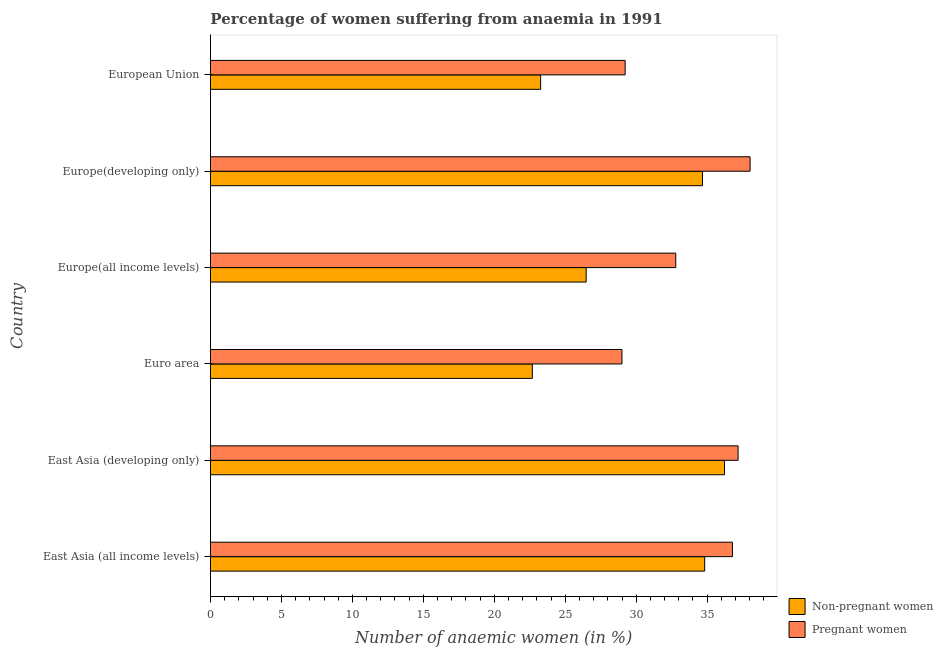How many different coloured bars are there?
Provide a succinct answer. 2. How many groups of bars are there?
Make the answer very short. 6. How many bars are there on the 3rd tick from the top?
Offer a very short reply. 2. How many bars are there on the 5th tick from the bottom?
Make the answer very short. 2. What is the label of the 1st group of bars from the top?
Your answer should be compact. European Union. In how many cases, is the number of bars for a given country not equal to the number of legend labels?
Your answer should be very brief. 0. What is the percentage of non-pregnant anaemic women in Europe(all income levels)?
Your answer should be compact. 26.47. Across all countries, what is the maximum percentage of pregnant anaemic women?
Make the answer very short. 38.02. Across all countries, what is the minimum percentage of pregnant anaemic women?
Offer a very short reply. 29. In which country was the percentage of pregnant anaemic women maximum?
Keep it short and to the point. Europe(developing only). What is the total percentage of non-pregnant anaemic women in the graph?
Keep it short and to the point. 178.14. What is the difference between the percentage of non-pregnant anaemic women in East Asia (developing only) and that in Europe(all income levels)?
Keep it short and to the point. 9.75. What is the difference between the percentage of non-pregnant anaemic women in Europe(developing only) and the percentage of pregnant anaemic women in Euro area?
Ensure brevity in your answer.  5.68. What is the average percentage of non-pregnant anaemic women per country?
Keep it short and to the point. 29.69. What is the difference between the percentage of pregnant anaemic women and percentage of non-pregnant anaemic women in Europe(developing only)?
Your response must be concise. 3.35. What is the ratio of the percentage of pregnant anaemic women in Europe(all income levels) to that in Europe(developing only)?
Make the answer very short. 0.86. Is the percentage of non-pregnant anaemic women in East Asia (developing only) less than that in Europe(all income levels)?
Your response must be concise. No. Is the difference between the percentage of pregnant anaemic women in East Asia (developing only) and Europe(developing only) greater than the difference between the percentage of non-pregnant anaemic women in East Asia (developing only) and Europe(developing only)?
Your answer should be very brief. No. What is the difference between the highest and the second highest percentage of non-pregnant anaemic women?
Provide a short and direct response. 1.4. What is the difference between the highest and the lowest percentage of non-pregnant anaemic women?
Your response must be concise. 13.54. In how many countries, is the percentage of non-pregnant anaemic women greater than the average percentage of non-pregnant anaemic women taken over all countries?
Your answer should be very brief. 3. Is the sum of the percentage of pregnant anaemic women in East Asia (all income levels) and East Asia (developing only) greater than the maximum percentage of non-pregnant anaemic women across all countries?
Make the answer very short. Yes. What does the 1st bar from the top in European Union represents?
Make the answer very short. Pregnant women. What does the 1st bar from the bottom in Euro area represents?
Provide a succinct answer. Non-pregnant women. How many bars are there?
Your response must be concise. 12. What is the difference between two consecutive major ticks on the X-axis?
Provide a short and direct response. 5. Does the graph contain grids?
Make the answer very short. No. Where does the legend appear in the graph?
Give a very brief answer. Bottom right. How are the legend labels stacked?
Offer a very short reply. Vertical. What is the title of the graph?
Your answer should be compact. Percentage of women suffering from anaemia in 1991. What is the label or title of the X-axis?
Provide a succinct answer. Number of anaemic women (in %). What is the Number of anaemic women (in %) of Non-pregnant women in East Asia (all income levels)?
Give a very brief answer. 34.83. What is the Number of anaemic women (in %) in Pregnant women in East Asia (all income levels)?
Offer a very short reply. 36.78. What is the Number of anaemic women (in %) in Non-pregnant women in East Asia (developing only)?
Make the answer very short. 36.22. What is the Number of anaemic women (in %) in Pregnant women in East Asia (developing only)?
Your answer should be very brief. 37.18. What is the Number of anaemic women (in %) of Non-pregnant women in Euro area?
Offer a terse response. 22.68. What is the Number of anaemic women (in %) of Pregnant women in Euro area?
Offer a terse response. 29. What is the Number of anaemic women (in %) of Non-pregnant women in Europe(all income levels)?
Offer a terse response. 26.47. What is the Number of anaemic women (in %) in Pregnant women in Europe(all income levels)?
Give a very brief answer. 32.79. What is the Number of anaemic women (in %) of Non-pregnant women in Europe(developing only)?
Your answer should be compact. 34.67. What is the Number of anaemic women (in %) in Pregnant women in Europe(developing only)?
Your answer should be very brief. 38.02. What is the Number of anaemic women (in %) of Non-pregnant women in European Union?
Your answer should be very brief. 23.27. What is the Number of anaemic women (in %) of Pregnant women in European Union?
Give a very brief answer. 29.22. Across all countries, what is the maximum Number of anaemic women (in %) of Non-pregnant women?
Ensure brevity in your answer.  36.22. Across all countries, what is the maximum Number of anaemic women (in %) in Pregnant women?
Give a very brief answer. 38.02. Across all countries, what is the minimum Number of anaemic women (in %) of Non-pregnant women?
Your answer should be compact. 22.68. Across all countries, what is the minimum Number of anaemic women (in %) in Pregnant women?
Your response must be concise. 29. What is the total Number of anaemic women (in %) in Non-pregnant women in the graph?
Offer a very short reply. 178.14. What is the total Number of anaemic women (in %) of Pregnant women in the graph?
Make the answer very short. 202.99. What is the difference between the Number of anaemic women (in %) of Non-pregnant women in East Asia (all income levels) and that in East Asia (developing only)?
Your response must be concise. -1.4. What is the difference between the Number of anaemic women (in %) of Pregnant women in East Asia (all income levels) and that in East Asia (developing only)?
Provide a succinct answer. -0.4. What is the difference between the Number of anaemic women (in %) in Non-pregnant women in East Asia (all income levels) and that in Euro area?
Your answer should be compact. 12.15. What is the difference between the Number of anaemic women (in %) of Pregnant women in East Asia (all income levels) and that in Euro area?
Your answer should be compact. 7.79. What is the difference between the Number of anaemic women (in %) of Non-pregnant women in East Asia (all income levels) and that in Europe(all income levels)?
Provide a succinct answer. 8.35. What is the difference between the Number of anaemic women (in %) of Pregnant women in East Asia (all income levels) and that in Europe(all income levels)?
Provide a succinct answer. 4. What is the difference between the Number of anaemic women (in %) of Non-pregnant women in East Asia (all income levels) and that in Europe(developing only)?
Keep it short and to the point. 0.15. What is the difference between the Number of anaemic women (in %) of Pregnant women in East Asia (all income levels) and that in Europe(developing only)?
Your answer should be very brief. -1.24. What is the difference between the Number of anaemic women (in %) in Non-pregnant women in East Asia (all income levels) and that in European Union?
Provide a succinct answer. 11.56. What is the difference between the Number of anaemic women (in %) of Pregnant women in East Asia (all income levels) and that in European Union?
Your response must be concise. 7.56. What is the difference between the Number of anaemic women (in %) of Non-pregnant women in East Asia (developing only) and that in Euro area?
Your answer should be very brief. 13.54. What is the difference between the Number of anaemic women (in %) of Pregnant women in East Asia (developing only) and that in Euro area?
Your answer should be compact. 8.18. What is the difference between the Number of anaemic women (in %) in Non-pregnant women in East Asia (developing only) and that in Europe(all income levels)?
Your response must be concise. 9.75. What is the difference between the Number of anaemic women (in %) in Pregnant women in East Asia (developing only) and that in Europe(all income levels)?
Provide a succinct answer. 4.39. What is the difference between the Number of anaemic women (in %) in Non-pregnant women in East Asia (developing only) and that in Europe(developing only)?
Your answer should be very brief. 1.55. What is the difference between the Number of anaemic women (in %) of Pregnant women in East Asia (developing only) and that in Europe(developing only)?
Your answer should be very brief. -0.85. What is the difference between the Number of anaemic women (in %) of Non-pregnant women in East Asia (developing only) and that in European Union?
Ensure brevity in your answer.  12.96. What is the difference between the Number of anaemic women (in %) in Pregnant women in East Asia (developing only) and that in European Union?
Offer a terse response. 7.96. What is the difference between the Number of anaemic women (in %) of Non-pregnant women in Euro area and that in Europe(all income levels)?
Give a very brief answer. -3.79. What is the difference between the Number of anaemic women (in %) in Pregnant women in Euro area and that in Europe(all income levels)?
Your answer should be very brief. -3.79. What is the difference between the Number of anaemic women (in %) of Non-pregnant women in Euro area and that in Europe(developing only)?
Offer a terse response. -11.99. What is the difference between the Number of anaemic women (in %) in Pregnant women in Euro area and that in Europe(developing only)?
Your answer should be very brief. -9.03. What is the difference between the Number of anaemic women (in %) in Non-pregnant women in Euro area and that in European Union?
Provide a succinct answer. -0.59. What is the difference between the Number of anaemic women (in %) of Pregnant women in Euro area and that in European Union?
Offer a very short reply. -0.23. What is the difference between the Number of anaemic women (in %) in Non-pregnant women in Europe(all income levels) and that in Europe(developing only)?
Your response must be concise. -8.2. What is the difference between the Number of anaemic women (in %) of Pregnant women in Europe(all income levels) and that in Europe(developing only)?
Give a very brief answer. -5.24. What is the difference between the Number of anaemic women (in %) in Non-pregnant women in Europe(all income levels) and that in European Union?
Give a very brief answer. 3.21. What is the difference between the Number of anaemic women (in %) of Pregnant women in Europe(all income levels) and that in European Union?
Provide a succinct answer. 3.57. What is the difference between the Number of anaemic women (in %) in Non-pregnant women in Europe(developing only) and that in European Union?
Give a very brief answer. 11.4. What is the difference between the Number of anaemic women (in %) of Pregnant women in Europe(developing only) and that in European Union?
Your answer should be very brief. 8.8. What is the difference between the Number of anaemic women (in %) in Non-pregnant women in East Asia (all income levels) and the Number of anaemic women (in %) in Pregnant women in East Asia (developing only)?
Your answer should be compact. -2.35. What is the difference between the Number of anaemic women (in %) of Non-pregnant women in East Asia (all income levels) and the Number of anaemic women (in %) of Pregnant women in Euro area?
Your answer should be compact. 5.83. What is the difference between the Number of anaemic women (in %) of Non-pregnant women in East Asia (all income levels) and the Number of anaemic women (in %) of Pregnant women in Europe(all income levels)?
Make the answer very short. 2.04. What is the difference between the Number of anaemic women (in %) of Non-pregnant women in East Asia (all income levels) and the Number of anaemic women (in %) of Pregnant women in Europe(developing only)?
Keep it short and to the point. -3.2. What is the difference between the Number of anaemic women (in %) of Non-pregnant women in East Asia (all income levels) and the Number of anaemic women (in %) of Pregnant women in European Union?
Give a very brief answer. 5.6. What is the difference between the Number of anaemic women (in %) in Non-pregnant women in East Asia (developing only) and the Number of anaemic women (in %) in Pregnant women in Euro area?
Make the answer very short. 7.23. What is the difference between the Number of anaemic women (in %) in Non-pregnant women in East Asia (developing only) and the Number of anaemic women (in %) in Pregnant women in Europe(all income levels)?
Your answer should be compact. 3.44. What is the difference between the Number of anaemic women (in %) of Non-pregnant women in East Asia (developing only) and the Number of anaemic women (in %) of Pregnant women in Europe(developing only)?
Keep it short and to the point. -1.8. What is the difference between the Number of anaemic women (in %) in Non-pregnant women in East Asia (developing only) and the Number of anaemic women (in %) in Pregnant women in European Union?
Give a very brief answer. 7. What is the difference between the Number of anaemic women (in %) of Non-pregnant women in Euro area and the Number of anaemic women (in %) of Pregnant women in Europe(all income levels)?
Your response must be concise. -10.11. What is the difference between the Number of anaemic women (in %) of Non-pregnant women in Euro area and the Number of anaemic women (in %) of Pregnant women in Europe(developing only)?
Your answer should be very brief. -15.34. What is the difference between the Number of anaemic women (in %) in Non-pregnant women in Euro area and the Number of anaemic women (in %) in Pregnant women in European Union?
Ensure brevity in your answer.  -6.54. What is the difference between the Number of anaemic women (in %) in Non-pregnant women in Europe(all income levels) and the Number of anaemic women (in %) in Pregnant women in Europe(developing only)?
Provide a short and direct response. -11.55. What is the difference between the Number of anaemic women (in %) in Non-pregnant women in Europe(all income levels) and the Number of anaemic women (in %) in Pregnant women in European Union?
Ensure brevity in your answer.  -2.75. What is the difference between the Number of anaemic women (in %) of Non-pregnant women in Europe(developing only) and the Number of anaemic women (in %) of Pregnant women in European Union?
Provide a succinct answer. 5.45. What is the average Number of anaemic women (in %) of Non-pregnant women per country?
Make the answer very short. 29.69. What is the average Number of anaemic women (in %) in Pregnant women per country?
Your response must be concise. 33.83. What is the difference between the Number of anaemic women (in %) in Non-pregnant women and Number of anaemic women (in %) in Pregnant women in East Asia (all income levels)?
Provide a short and direct response. -1.96. What is the difference between the Number of anaemic women (in %) in Non-pregnant women and Number of anaemic women (in %) in Pregnant women in East Asia (developing only)?
Provide a short and direct response. -0.96. What is the difference between the Number of anaemic women (in %) in Non-pregnant women and Number of anaemic women (in %) in Pregnant women in Euro area?
Offer a very short reply. -6.32. What is the difference between the Number of anaemic women (in %) in Non-pregnant women and Number of anaemic women (in %) in Pregnant women in Europe(all income levels)?
Make the answer very short. -6.31. What is the difference between the Number of anaemic women (in %) of Non-pregnant women and Number of anaemic women (in %) of Pregnant women in Europe(developing only)?
Offer a terse response. -3.35. What is the difference between the Number of anaemic women (in %) in Non-pregnant women and Number of anaemic women (in %) in Pregnant women in European Union?
Your answer should be very brief. -5.95. What is the ratio of the Number of anaemic women (in %) in Non-pregnant women in East Asia (all income levels) to that in East Asia (developing only)?
Provide a succinct answer. 0.96. What is the ratio of the Number of anaemic women (in %) in Pregnant women in East Asia (all income levels) to that in East Asia (developing only)?
Your response must be concise. 0.99. What is the ratio of the Number of anaemic women (in %) of Non-pregnant women in East Asia (all income levels) to that in Euro area?
Ensure brevity in your answer.  1.54. What is the ratio of the Number of anaemic women (in %) in Pregnant women in East Asia (all income levels) to that in Euro area?
Your answer should be compact. 1.27. What is the ratio of the Number of anaemic women (in %) of Non-pregnant women in East Asia (all income levels) to that in Europe(all income levels)?
Your answer should be compact. 1.32. What is the ratio of the Number of anaemic women (in %) in Pregnant women in East Asia (all income levels) to that in Europe(all income levels)?
Your answer should be compact. 1.12. What is the ratio of the Number of anaemic women (in %) in Pregnant women in East Asia (all income levels) to that in Europe(developing only)?
Your answer should be compact. 0.97. What is the ratio of the Number of anaemic women (in %) in Non-pregnant women in East Asia (all income levels) to that in European Union?
Give a very brief answer. 1.5. What is the ratio of the Number of anaemic women (in %) in Pregnant women in East Asia (all income levels) to that in European Union?
Keep it short and to the point. 1.26. What is the ratio of the Number of anaemic women (in %) in Non-pregnant women in East Asia (developing only) to that in Euro area?
Offer a very short reply. 1.6. What is the ratio of the Number of anaemic women (in %) in Pregnant women in East Asia (developing only) to that in Euro area?
Your answer should be compact. 1.28. What is the ratio of the Number of anaemic women (in %) of Non-pregnant women in East Asia (developing only) to that in Europe(all income levels)?
Offer a terse response. 1.37. What is the ratio of the Number of anaemic women (in %) of Pregnant women in East Asia (developing only) to that in Europe(all income levels)?
Give a very brief answer. 1.13. What is the ratio of the Number of anaemic women (in %) of Non-pregnant women in East Asia (developing only) to that in Europe(developing only)?
Ensure brevity in your answer.  1.04. What is the ratio of the Number of anaemic women (in %) in Pregnant women in East Asia (developing only) to that in Europe(developing only)?
Ensure brevity in your answer.  0.98. What is the ratio of the Number of anaemic women (in %) of Non-pregnant women in East Asia (developing only) to that in European Union?
Your response must be concise. 1.56. What is the ratio of the Number of anaemic women (in %) in Pregnant women in East Asia (developing only) to that in European Union?
Make the answer very short. 1.27. What is the ratio of the Number of anaemic women (in %) in Non-pregnant women in Euro area to that in Europe(all income levels)?
Your answer should be compact. 0.86. What is the ratio of the Number of anaemic women (in %) in Pregnant women in Euro area to that in Europe(all income levels)?
Make the answer very short. 0.88. What is the ratio of the Number of anaemic women (in %) of Non-pregnant women in Euro area to that in Europe(developing only)?
Give a very brief answer. 0.65. What is the ratio of the Number of anaemic women (in %) in Pregnant women in Euro area to that in Europe(developing only)?
Make the answer very short. 0.76. What is the ratio of the Number of anaemic women (in %) in Non-pregnant women in Euro area to that in European Union?
Give a very brief answer. 0.97. What is the ratio of the Number of anaemic women (in %) in Non-pregnant women in Europe(all income levels) to that in Europe(developing only)?
Provide a short and direct response. 0.76. What is the ratio of the Number of anaemic women (in %) of Pregnant women in Europe(all income levels) to that in Europe(developing only)?
Your answer should be compact. 0.86. What is the ratio of the Number of anaemic women (in %) of Non-pregnant women in Europe(all income levels) to that in European Union?
Your response must be concise. 1.14. What is the ratio of the Number of anaemic women (in %) of Pregnant women in Europe(all income levels) to that in European Union?
Provide a succinct answer. 1.12. What is the ratio of the Number of anaemic women (in %) in Non-pregnant women in Europe(developing only) to that in European Union?
Your response must be concise. 1.49. What is the ratio of the Number of anaemic women (in %) of Pregnant women in Europe(developing only) to that in European Union?
Offer a very short reply. 1.3. What is the difference between the highest and the second highest Number of anaemic women (in %) of Non-pregnant women?
Provide a succinct answer. 1.4. What is the difference between the highest and the second highest Number of anaemic women (in %) in Pregnant women?
Keep it short and to the point. 0.85. What is the difference between the highest and the lowest Number of anaemic women (in %) in Non-pregnant women?
Offer a very short reply. 13.54. What is the difference between the highest and the lowest Number of anaemic women (in %) of Pregnant women?
Your answer should be compact. 9.03. 